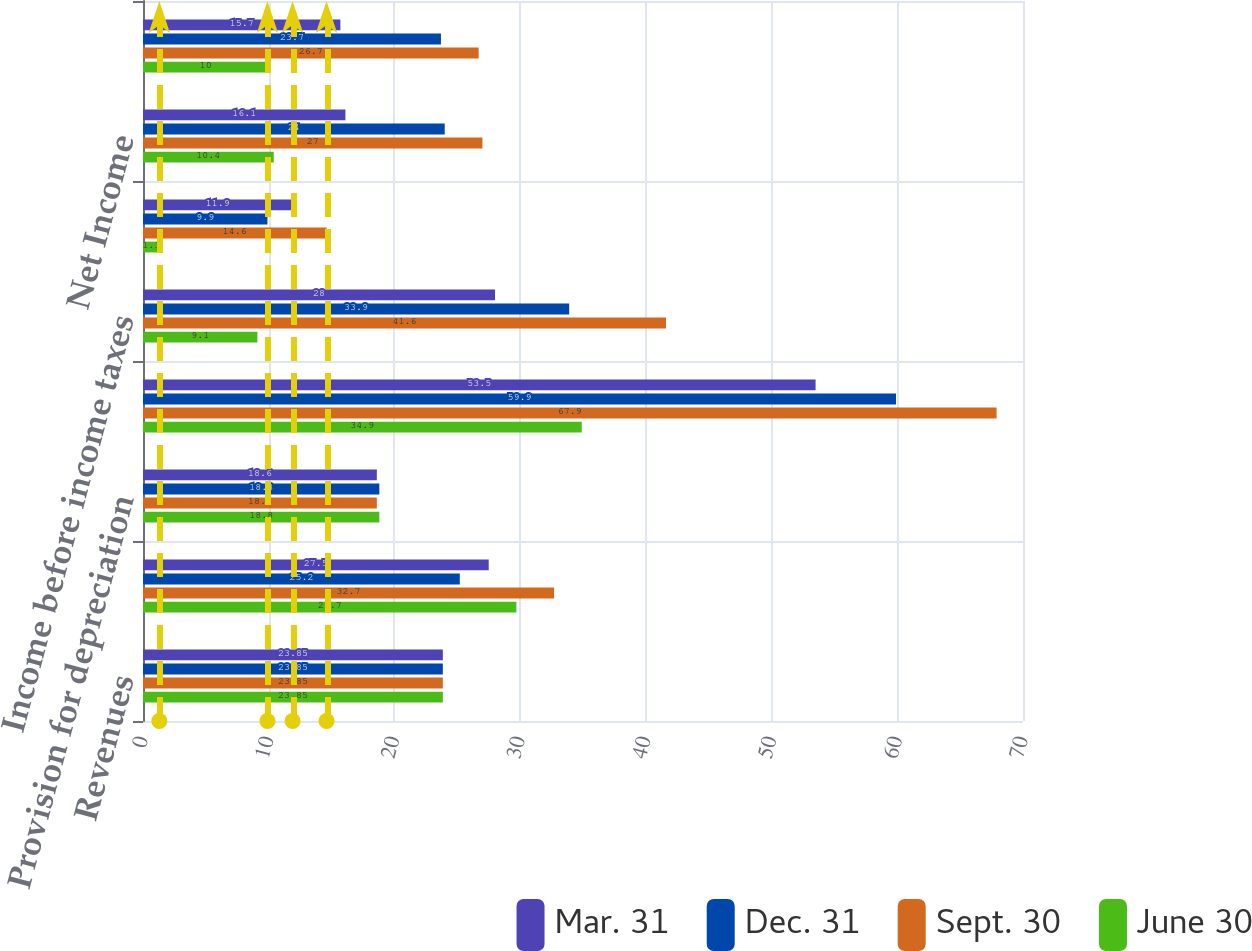Convert chart to OTSL. <chart><loc_0><loc_0><loc_500><loc_500><stacked_bar_chart><ecel><fcel>Revenues<fcel>Other operating expense<fcel>Provision for depreciation<fcel>Operating Income<fcel>Income before income taxes<fcel>Income taxes<fcel>Net Income<fcel>Earnings available to Parent<nl><fcel>Mar. 31<fcel>23.85<fcel>27.5<fcel>18.6<fcel>53.5<fcel>28<fcel>11.9<fcel>16.1<fcel>15.7<nl><fcel>Dec. 31<fcel>23.85<fcel>25.2<fcel>18.8<fcel>59.9<fcel>33.9<fcel>9.9<fcel>24<fcel>23.7<nl><fcel>Sept. 30<fcel>23.85<fcel>32.7<fcel>18.6<fcel>67.9<fcel>41.6<fcel>14.6<fcel>27<fcel>26.7<nl><fcel>June 30<fcel>23.85<fcel>29.7<fcel>18.8<fcel>34.9<fcel>9.1<fcel>1.3<fcel>10.4<fcel>10<nl></chart> 